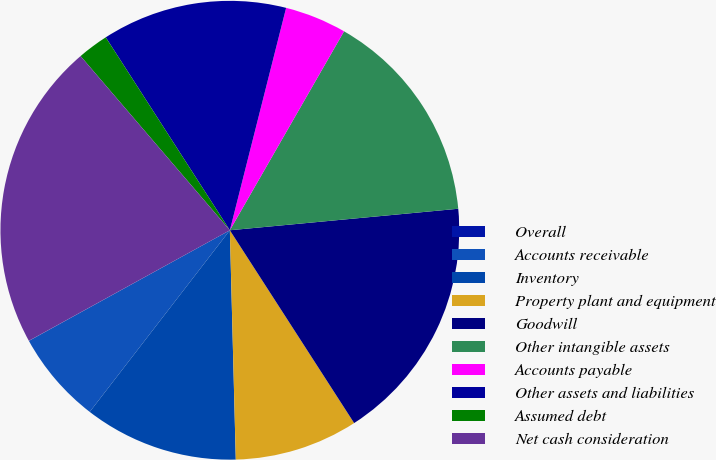<chart> <loc_0><loc_0><loc_500><loc_500><pie_chart><fcel>Overall<fcel>Accounts receivable<fcel>Inventory<fcel>Property plant and equipment<fcel>Goodwill<fcel>Other intangible assets<fcel>Accounts payable<fcel>Other assets and liabilities<fcel>Assumed debt<fcel>Net cash consideration<nl><fcel>0.01%<fcel>6.53%<fcel>10.87%<fcel>8.7%<fcel>17.38%<fcel>15.21%<fcel>4.35%<fcel>13.04%<fcel>2.18%<fcel>21.72%<nl></chart> 